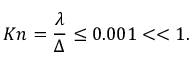Convert formula to latex. <formula><loc_0><loc_0><loc_500><loc_500>K n = \frac { \lambda } { \Delta } \leq 0 . 0 0 1 < < 1 .</formula> 